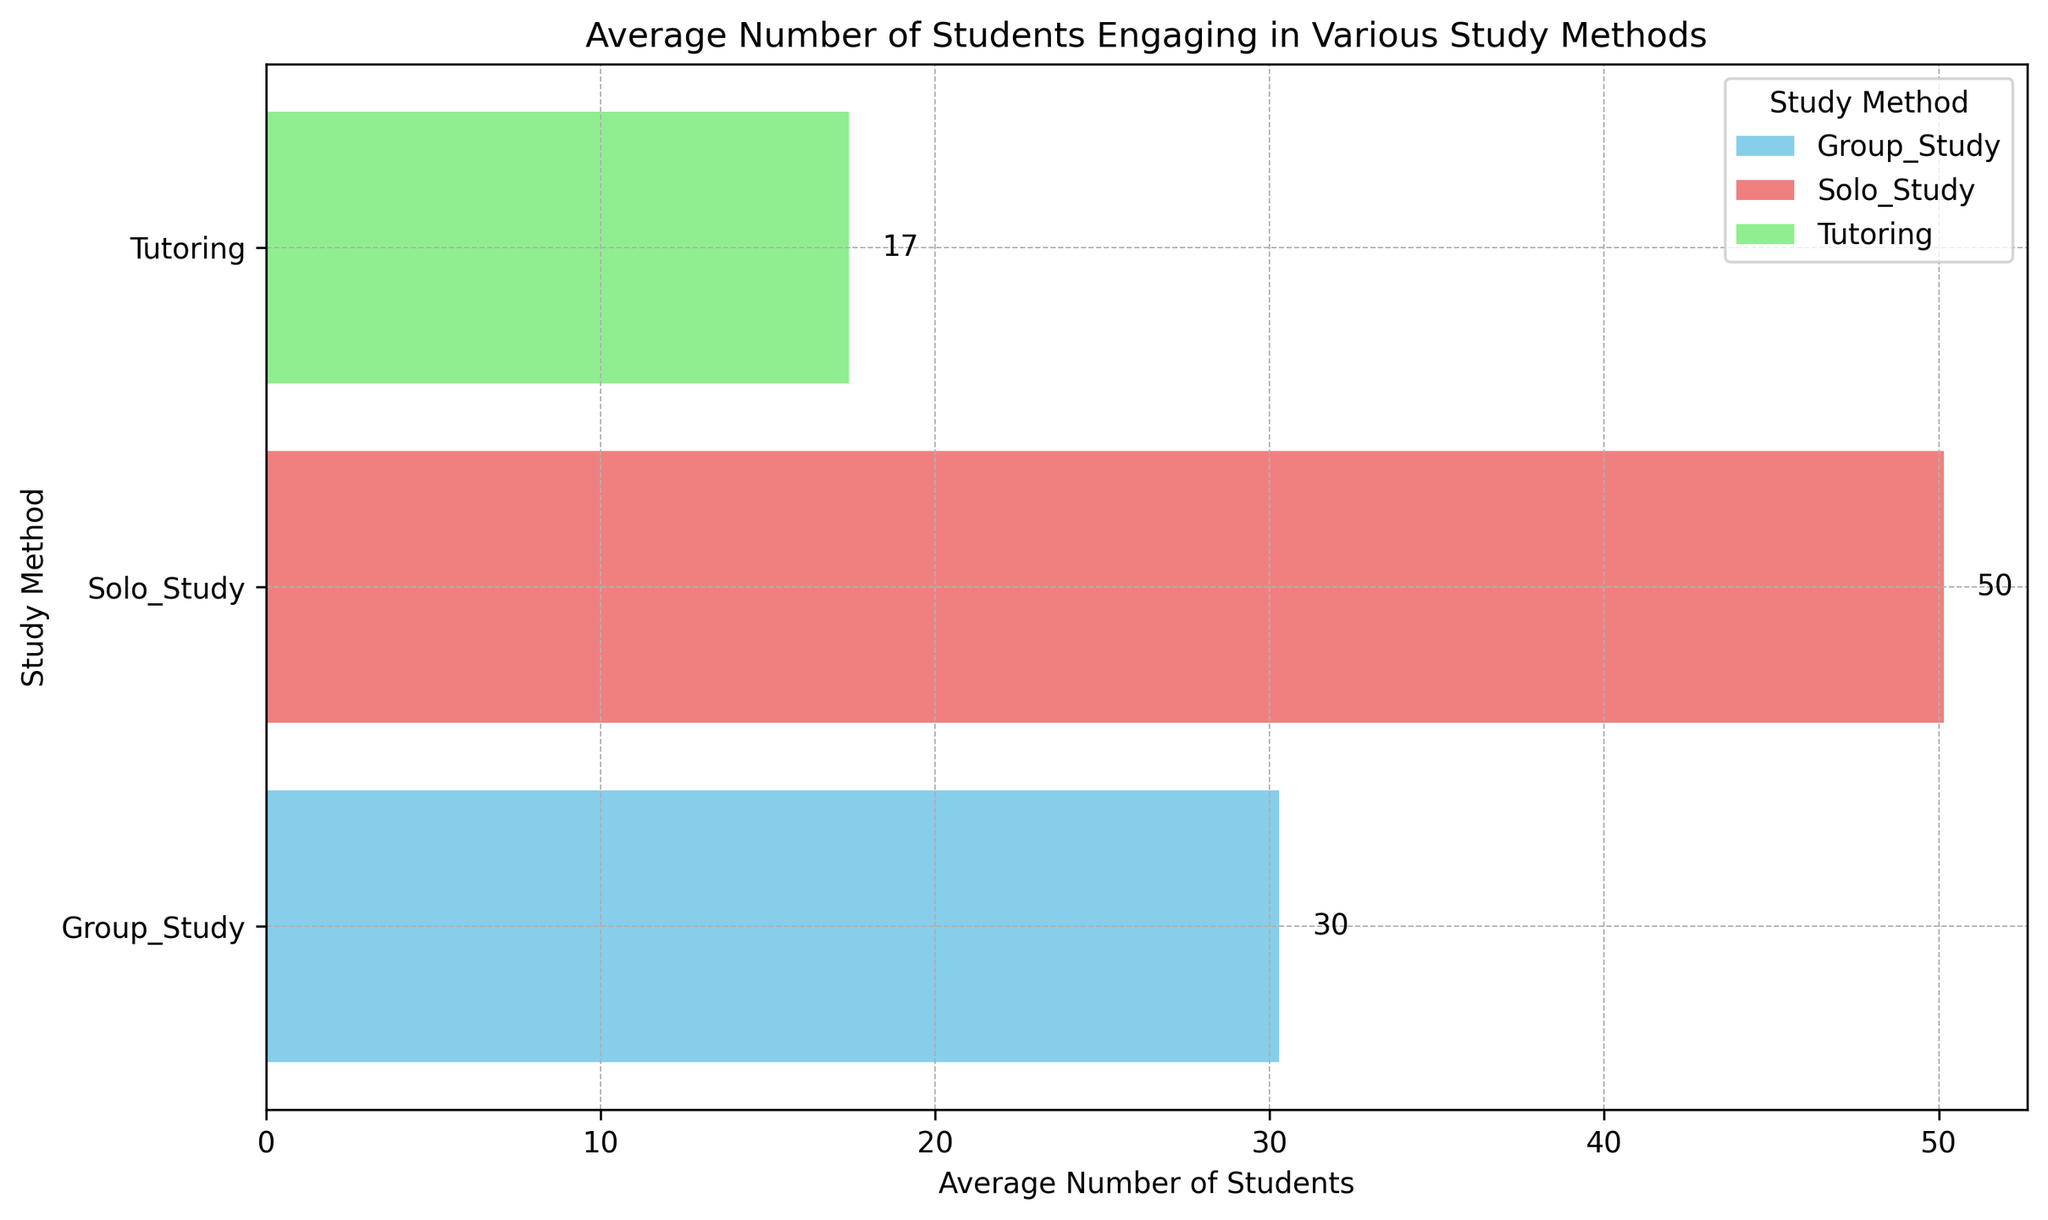What's the average number of students engaging in Solo Study? To find the average, sum the number of students engaging in Solo Study: 50 + 45 + 40 + 55 + 60 + 53 + 48 = 351. Since there are 7 instances of Solo Study, divide this sum by 7: 351 / 7 = 50.14
Answer: 50.14 Which study method has the highest average number of students? By comparing the average number of students for Group Study (30.33), Solo Study (50.14), and Tutoring (17.43), we see that the Solo Study method has the highest average.
Answer: Solo Study What's the total number of students engaging in Group Study and Solo Study combined? Sum the average number of students for Group Study (30.33) and Solo Study (50.14): 30.33 + 50.14 = 80.47
Answer: 80.47 Between Group Study and Tutoring, which method has a higher reported effectiveness? Group Study has an average reported effectiveness of 74.71, while Tutoring has an average reported effectiveness of 79.57. Tutoring has the higher effectiveness.
Answer: Tutoring What is the difference in the average number of students between Solo Study and Tutoring? Subtract the average number of students for Tutoring (17.43) from Solo Study (50.14): 50.14 - 17.43 = 32.71
Answer: 32.71 Which study method is represented by the light green bar in the plot? In the figure, light green corresponds to the Tutoring study method.
Answer: Tutoring Are there more students engaging in Group Study or Tutoring on average? Compare the average numbers: Group Study (30.33) and Tutoring (17.43). There are more students engaging in Group Study.
Answer: Group Study By how much does the reported effectiveness for Solo Study exceed that of Group Study on average? Subtract the average reported effectiveness of Group Study (74.71) from Solo Study (85): 85 - 74.71 = 10.29
Answer: 10.29 